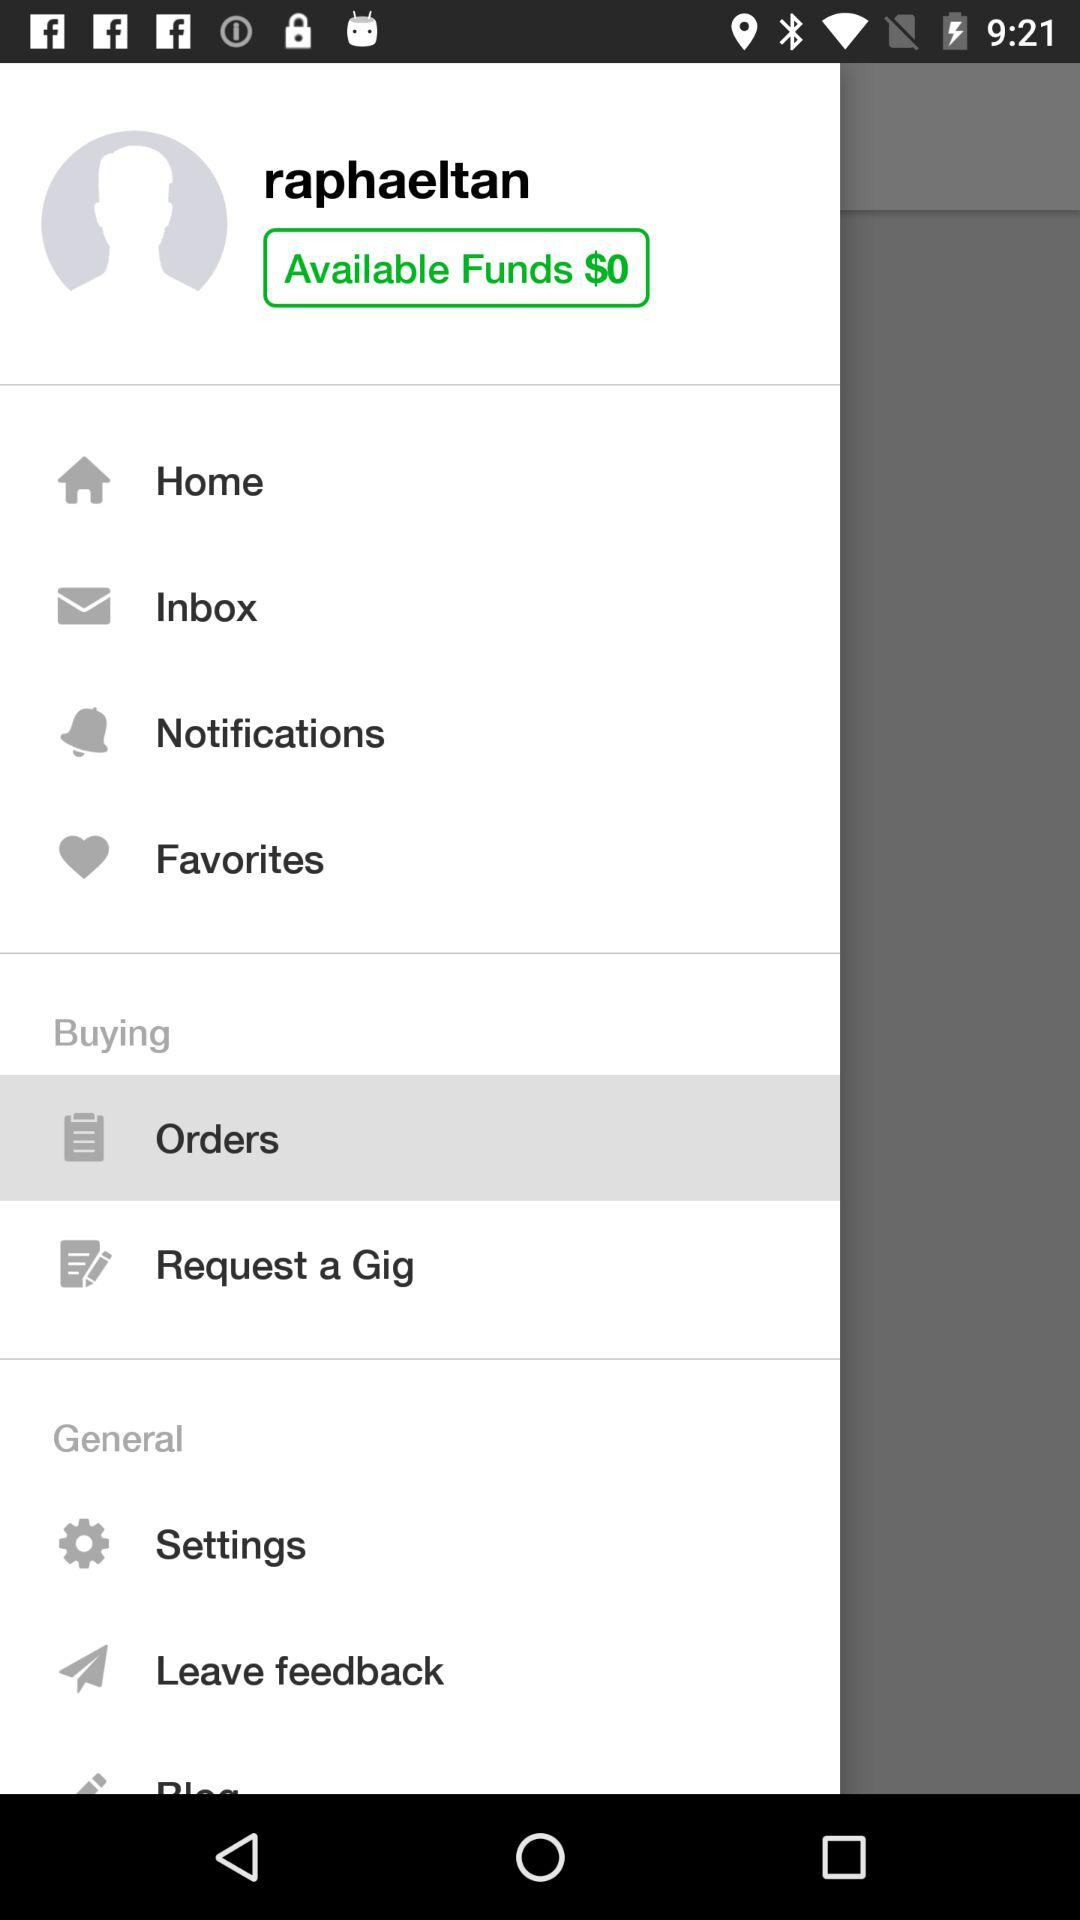Which tab is selected? The selected tab is "Orders". 